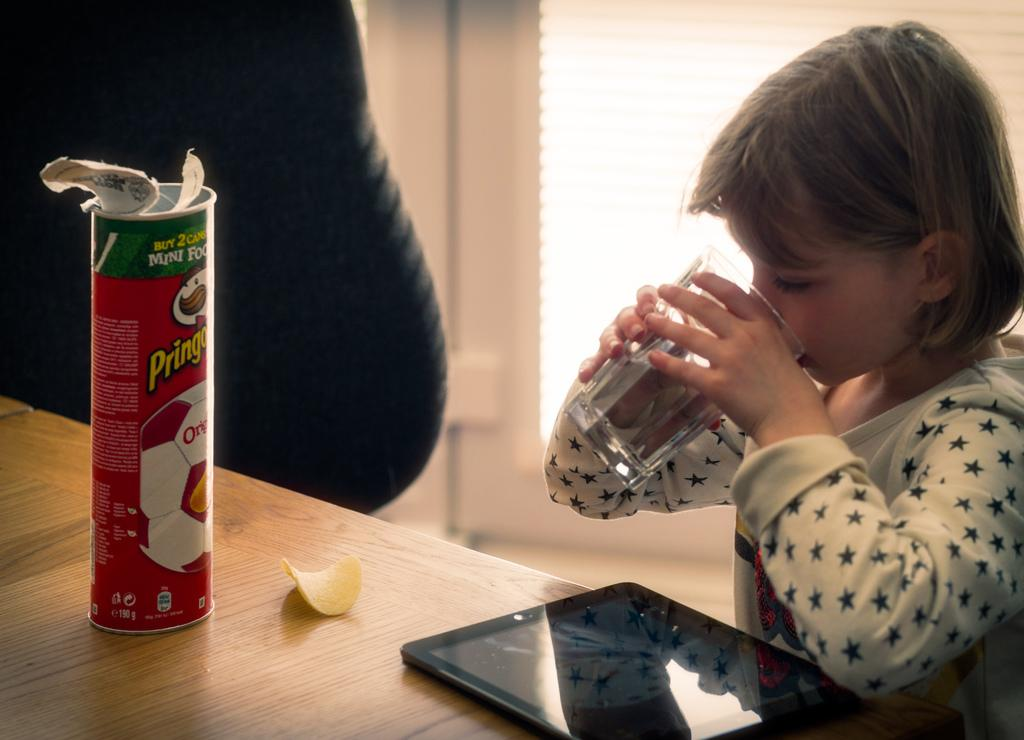Who is present in the image? There is a girl in the image. What is the girl doing in the image? The girl is drinking water with a glass. What is the primary piece of furniture in the image? There is a table in the image. What items can be seen on the table? There is a tab, chips, and a box on the table. What type of harmony is being played on the guitar in the image? There is no guitar present in the image; it features a girl drinking water with a glass and items on a table. 